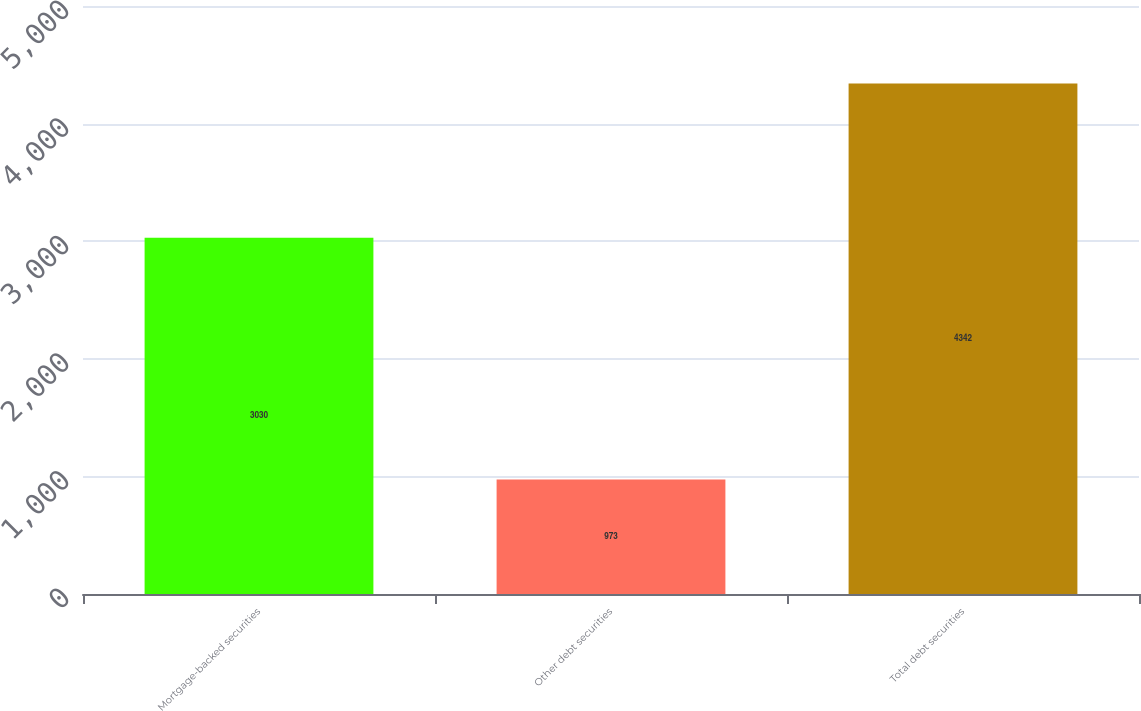Convert chart to OTSL. <chart><loc_0><loc_0><loc_500><loc_500><bar_chart><fcel>Mortgage-backed securities<fcel>Other debt securities<fcel>Total debt securities<nl><fcel>3030<fcel>973<fcel>4342<nl></chart> 